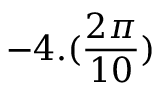Convert formula to latex. <formula><loc_0><loc_0><loc_500><loc_500>- 4 . ( \frac { 2 \pi } { 1 0 } )</formula> 